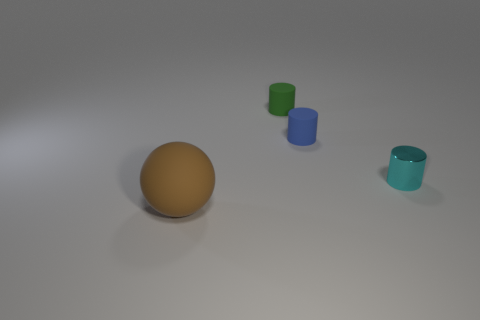Add 2 tiny yellow rubber balls. How many objects exist? 6 Subtract all small green rubber cylinders. How many cylinders are left? 2 Subtract 1 spheres. How many spheres are left? 0 Subtract all green cylinders. How many cylinders are left? 2 Subtract all green balls. Subtract all cyan cylinders. How many balls are left? 1 Subtract all green spheres. How many blue cylinders are left? 1 Subtract all tiny green matte things. Subtract all shiny cylinders. How many objects are left? 2 Add 3 blue cylinders. How many blue cylinders are left? 4 Add 4 cyan objects. How many cyan objects exist? 5 Subtract 1 blue cylinders. How many objects are left? 3 